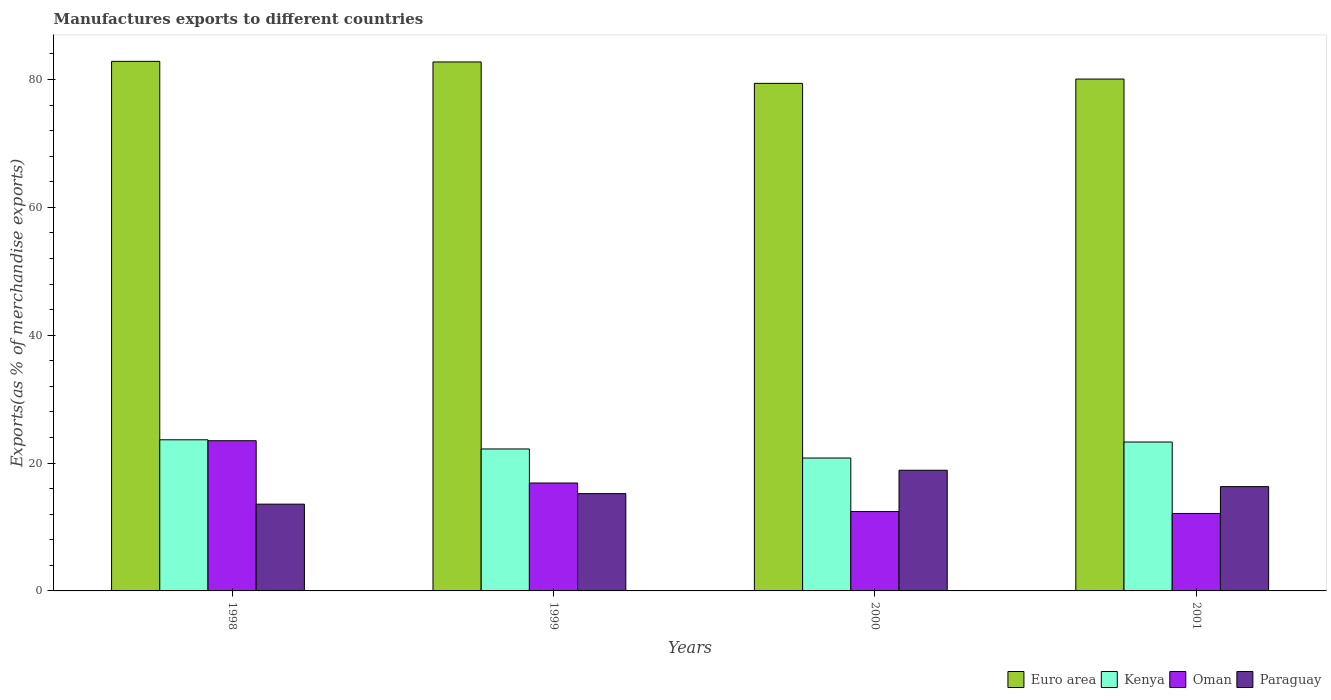Are the number of bars per tick equal to the number of legend labels?
Make the answer very short. Yes. Are the number of bars on each tick of the X-axis equal?
Ensure brevity in your answer.  Yes. How many bars are there on the 4th tick from the left?
Offer a very short reply. 4. What is the label of the 1st group of bars from the left?
Give a very brief answer. 1998. What is the percentage of exports to different countries in Paraguay in 1999?
Provide a short and direct response. 15.22. Across all years, what is the maximum percentage of exports to different countries in Kenya?
Offer a terse response. 23.64. Across all years, what is the minimum percentage of exports to different countries in Euro area?
Your answer should be very brief. 79.39. What is the total percentage of exports to different countries in Euro area in the graph?
Provide a succinct answer. 325.02. What is the difference between the percentage of exports to different countries in Paraguay in 1998 and that in 1999?
Your response must be concise. -1.65. What is the difference between the percentage of exports to different countries in Kenya in 2000 and the percentage of exports to different countries in Paraguay in 1998?
Offer a very short reply. 7.21. What is the average percentage of exports to different countries in Oman per year?
Offer a very short reply. 16.23. In the year 2000, what is the difference between the percentage of exports to different countries in Euro area and percentage of exports to different countries in Paraguay?
Provide a short and direct response. 60.51. What is the ratio of the percentage of exports to different countries in Paraguay in 1999 to that in 2001?
Make the answer very short. 0.93. Is the percentage of exports to different countries in Paraguay in 1998 less than that in 1999?
Make the answer very short. Yes. Is the difference between the percentage of exports to different countries in Euro area in 2000 and 2001 greater than the difference between the percentage of exports to different countries in Paraguay in 2000 and 2001?
Your answer should be very brief. No. What is the difference between the highest and the second highest percentage of exports to different countries in Euro area?
Give a very brief answer. 0.09. What is the difference between the highest and the lowest percentage of exports to different countries in Paraguay?
Offer a very short reply. 5.3. Is the sum of the percentage of exports to different countries in Oman in 2000 and 2001 greater than the maximum percentage of exports to different countries in Paraguay across all years?
Your response must be concise. Yes. Is it the case that in every year, the sum of the percentage of exports to different countries in Kenya and percentage of exports to different countries in Paraguay is greater than the sum of percentage of exports to different countries in Euro area and percentage of exports to different countries in Oman?
Ensure brevity in your answer.  Yes. What does the 2nd bar from the left in 1998 represents?
Your answer should be very brief. Kenya. What does the 1st bar from the right in 1998 represents?
Provide a succinct answer. Paraguay. Is it the case that in every year, the sum of the percentage of exports to different countries in Kenya and percentage of exports to different countries in Oman is greater than the percentage of exports to different countries in Paraguay?
Keep it short and to the point. Yes. Are all the bars in the graph horizontal?
Ensure brevity in your answer.  No. What is the difference between two consecutive major ticks on the Y-axis?
Your answer should be compact. 20. Are the values on the major ticks of Y-axis written in scientific E-notation?
Ensure brevity in your answer.  No. How are the legend labels stacked?
Your answer should be compact. Horizontal. What is the title of the graph?
Keep it short and to the point. Manufactures exports to different countries. What is the label or title of the X-axis?
Provide a succinct answer. Years. What is the label or title of the Y-axis?
Provide a succinct answer. Exports(as % of merchandise exports). What is the Exports(as % of merchandise exports) of Euro area in 1998?
Provide a succinct answer. 82.83. What is the Exports(as % of merchandise exports) in Kenya in 1998?
Give a very brief answer. 23.64. What is the Exports(as % of merchandise exports) in Oman in 1998?
Make the answer very short. 23.49. What is the Exports(as % of merchandise exports) in Paraguay in 1998?
Your response must be concise. 13.57. What is the Exports(as % of merchandise exports) in Euro area in 1999?
Your answer should be compact. 82.74. What is the Exports(as % of merchandise exports) in Kenya in 1999?
Give a very brief answer. 22.2. What is the Exports(as % of merchandise exports) of Oman in 1999?
Provide a succinct answer. 16.88. What is the Exports(as % of merchandise exports) of Paraguay in 1999?
Keep it short and to the point. 15.22. What is the Exports(as % of merchandise exports) in Euro area in 2000?
Provide a short and direct response. 79.39. What is the Exports(as % of merchandise exports) in Kenya in 2000?
Offer a terse response. 20.79. What is the Exports(as % of merchandise exports) in Oman in 2000?
Ensure brevity in your answer.  12.42. What is the Exports(as % of merchandise exports) in Paraguay in 2000?
Offer a very short reply. 18.88. What is the Exports(as % of merchandise exports) of Euro area in 2001?
Keep it short and to the point. 80.06. What is the Exports(as % of merchandise exports) in Kenya in 2001?
Offer a very short reply. 23.29. What is the Exports(as % of merchandise exports) in Oman in 2001?
Offer a very short reply. 12.12. What is the Exports(as % of merchandise exports) of Paraguay in 2001?
Your response must be concise. 16.31. Across all years, what is the maximum Exports(as % of merchandise exports) in Euro area?
Offer a terse response. 82.83. Across all years, what is the maximum Exports(as % of merchandise exports) of Kenya?
Your answer should be very brief. 23.64. Across all years, what is the maximum Exports(as % of merchandise exports) of Oman?
Make the answer very short. 23.49. Across all years, what is the maximum Exports(as % of merchandise exports) of Paraguay?
Provide a short and direct response. 18.88. Across all years, what is the minimum Exports(as % of merchandise exports) of Euro area?
Provide a succinct answer. 79.39. Across all years, what is the minimum Exports(as % of merchandise exports) of Kenya?
Offer a very short reply. 20.79. Across all years, what is the minimum Exports(as % of merchandise exports) in Oman?
Your response must be concise. 12.12. Across all years, what is the minimum Exports(as % of merchandise exports) in Paraguay?
Your answer should be compact. 13.57. What is the total Exports(as % of merchandise exports) in Euro area in the graph?
Your response must be concise. 325.02. What is the total Exports(as % of merchandise exports) of Kenya in the graph?
Offer a terse response. 89.92. What is the total Exports(as % of merchandise exports) of Oman in the graph?
Ensure brevity in your answer.  64.9. What is the total Exports(as % of merchandise exports) in Paraguay in the graph?
Keep it short and to the point. 63.98. What is the difference between the Exports(as % of merchandise exports) of Euro area in 1998 and that in 1999?
Make the answer very short. 0.09. What is the difference between the Exports(as % of merchandise exports) of Kenya in 1998 and that in 1999?
Your answer should be compact. 1.44. What is the difference between the Exports(as % of merchandise exports) of Oman in 1998 and that in 1999?
Your answer should be compact. 6.61. What is the difference between the Exports(as % of merchandise exports) in Paraguay in 1998 and that in 1999?
Your answer should be compact. -1.65. What is the difference between the Exports(as % of merchandise exports) of Euro area in 1998 and that in 2000?
Keep it short and to the point. 3.44. What is the difference between the Exports(as % of merchandise exports) of Kenya in 1998 and that in 2000?
Your response must be concise. 2.85. What is the difference between the Exports(as % of merchandise exports) of Oman in 1998 and that in 2000?
Your answer should be very brief. 11.08. What is the difference between the Exports(as % of merchandise exports) of Paraguay in 1998 and that in 2000?
Make the answer very short. -5.3. What is the difference between the Exports(as % of merchandise exports) in Euro area in 1998 and that in 2001?
Offer a very short reply. 2.77. What is the difference between the Exports(as % of merchandise exports) in Kenya in 1998 and that in 2001?
Keep it short and to the point. 0.35. What is the difference between the Exports(as % of merchandise exports) in Oman in 1998 and that in 2001?
Keep it short and to the point. 11.38. What is the difference between the Exports(as % of merchandise exports) in Paraguay in 1998 and that in 2001?
Provide a succinct answer. -2.74. What is the difference between the Exports(as % of merchandise exports) of Euro area in 1999 and that in 2000?
Your response must be concise. 3.35. What is the difference between the Exports(as % of merchandise exports) in Kenya in 1999 and that in 2000?
Offer a very short reply. 1.42. What is the difference between the Exports(as % of merchandise exports) of Oman in 1999 and that in 2000?
Keep it short and to the point. 4.46. What is the difference between the Exports(as % of merchandise exports) of Paraguay in 1999 and that in 2000?
Give a very brief answer. -3.66. What is the difference between the Exports(as % of merchandise exports) of Euro area in 1999 and that in 2001?
Offer a very short reply. 2.67. What is the difference between the Exports(as % of merchandise exports) in Kenya in 1999 and that in 2001?
Make the answer very short. -1.09. What is the difference between the Exports(as % of merchandise exports) of Oman in 1999 and that in 2001?
Offer a terse response. 4.76. What is the difference between the Exports(as % of merchandise exports) in Paraguay in 1999 and that in 2001?
Your response must be concise. -1.09. What is the difference between the Exports(as % of merchandise exports) of Euro area in 2000 and that in 2001?
Your response must be concise. -0.67. What is the difference between the Exports(as % of merchandise exports) in Kenya in 2000 and that in 2001?
Ensure brevity in your answer.  -2.5. What is the difference between the Exports(as % of merchandise exports) of Oman in 2000 and that in 2001?
Offer a terse response. 0.3. What is the difference between the Exports(as % of merchandise exports) in Paraguay in 2000 and that in 2001?
Your answer should be very brief. 2.56. What is the difference between the Exports(as % of merchandise exports) in Euro area in 1998 and the Exports(as % of merchandise exports) in Kenya in 1999?
Your response must be concise. 60.63. What is the difference between the Exports(as % of merchandise exports) of Euro area in 1998 and the Exports(as % of merchandise exports) of Oman in 1999?
Your response must be concise. 65.95. What is the difference between the Exports(as % of merchandise exports) in Euro area in 1998 and the Exports(as % of merchandise exports) in Paraguay in 1999?
Your answer should be very brief. 67.61. What is the difference between the Exports(as % of merchandise exports) in Kenya in 1998 and the Exports(as % of merchandise exports) in Oman in 1999?
Give a very brief answer. 6.76. What is the difference between the Exports(as % of merchandise exports) in Kenya in 1998 and the Exports(as % of merchandise exports) in Paraguay in 1999?
Your response must be concise. 8.42. What is the difference between the Exports(as % of merchandise exports) of Oman in 1998 and the Exports(as % of merchandise exports) of Paraguay in 1999?
Your answer should be very brief. 8.27. What is the difference between the Exports(as % of merchandise exports) in Euro area in 1998 and the Exports(as % of merchandise exports) in Kenya in 2000?
Your answer should be very brief. 62.04. What is the difference between the Exports(as % of merchandise exports) in Euro area in 1998 and the Exports(as % of merchandise exports) in Oman in 2000?
Ensure brevity in your answer.  70.42. What is the difference between the Exports(as % of merchandise exports) in Euro area in 1998 and the Exports(as % of merchandise exports) in Paraguay in 2000?
Provide a succinct answer. 63.95. What is the difference between the Exports(as % of merchandise exports) of Kenya in 1998 and the Exports(as % of merchandise exports) of Oman in 2000?
Your response must be concise. 11.22. What is the difference between the Exports(as % of merchandise exports) of Kenya in 1998 and the Exports(as % of merchandise exports) of Paraguay in 2000?
Offer a very short reply. 4.76. What is the difference between the Exports(as % of merchandise exports) of Oman in 1998 and the Exports(as % of merchandise exports) of Paraguay in 2000?
Give a very brief answer. 4.62. What is the difference between the Exports(as % of merchandise exports) in Euro area in 1998 and the Exports(as % of merchandise exports) in Kenya in 2001?
Your answer should be very brief. 59.54. What is the difference between the Exports(as % of merchandise exports) in Euro area in 1998 and the Exports(as % of merchandise exports) in Oman in 2001?
Ensure brevity in your answer.  70.72. What is the difference between the Exports(as % of merchandise exports) in Euro area in 1998 and the Exports(as % of merchandise exports) in Paraguay in 2001?
Your answer should be compact. 66.52. What is the difference between the Exports(as % of merchandise exports) in Kenya in 1998 and the Exports(as % of merchandise exports) in Oman in 2001?
Ensure brevity in your answer.  11.52. What is the difference between the Exports(as % of merchandise exports) in Kenya in 1998 and the Exports(as % of merchandise exports) in Paraguay in 2001?
Keep it short and to the point. 7.33. What is the difference between the Exports(as % of merchandise exports) in Oman in 1998 and the Exports(as % of merchandise exports) in Paraguay in 2001?
Make the answer very short. 7.18. What is the difference between the Exports(as % of merchandise exports) in Euro area in 1999 and the Exports(as % of merchandise exports) in Kenya in 2000?
Your answer should be compact. 61.95. What is the difference between the Exports(as % of merchandise exports) of Euro area in 1999 and the Exports(as % of merchandise exports) of Oman in 2000?
Offer a terse response. 70.32. What is the difference between the Exports(as % of merchandise exports) of Euro area in 1999 and the Exports(as % of merchandise exports) of Paraguay in 2000?
Keep it short and to the point. 63.86. What is the difference between the Exports(as % of merchandise exports) in Kenya in 1999 and the Exports(as % of merchandise exports) in Oman in 2000?
Your answer should be very brief. 9.79. What is the difference between the Exports(as % of merchandise exports) of Kenya in 1999 and the Exports(as % of merchandise exports) of Paraguay in 2000?
Make the answer very short. 3.33. What is the difference between the Exports(as % of merchandise exports) in Oman in 1999 and the Exports(as % of merchandise exports) in Paraguay in 2000?
Your answer should be compact. -2. What is the difference between the Exports(as % of merchandise exports) of Euro area in 1999 and the Exports(as % of merchandise exports) of Kenya in 2001?
Offer a very short reply. 59.45. What is the difference between the Exports(as % of merchandise exports) in Euro area in 1999 and the Exports(as % of merchandise exports) in Oman in 2001?
Keep it short and to the point. 70.62. What is the difference between the Exports(as % of merchandise exports) of Euro area in 1999 and the Exports(as % of merchandise exports) of Paraguay in 2001?
Ensure brevity in your answer.  66.42. What is the difference between the Exports(as % of merchandise exports) in Kenya in 1999 and the Exports(as % of merchandise exports) in Oman in 2001?
Provide a short and direct response. 10.09. What is the difference between the Exports(as % of merchandise exports) in Kenya in 1999 and the Exports(as % of merchandise exports) in Paraguay in 2001?
Your answer should be compact. 5.89. What is the difference between the Exports(as % of merchandise exports) of Oman in 1999 and the Exports(as % of merchandise exports) of Paraguay in 2001?
Your answer should be very brief. 0.57. What is the difference between the Exports(as % of merchandise exports) in Euro area in 2000 and the Exports(as % of merchandise exports) in Kenya in 2001?
Keep it short and to the point. 56.1. What is the difference between the Exports(as % of merchandise exports) in Euro area in 2000 and the Exports(as % of merchandise exports) in Oman in 2001?
Offer a very short reply. 67.27. What is the difference between the Exports(as % of merchandise exports) in Euro area in 2000 and the Exports(as % of merchandise exports) in Paraguay in 2001?
Provide a succinct answer. 63.07. What is the difference between the Exports(as % of merchandise exports) of Kenya in 2000 and the Exports(as % of merchandise exports) of Oman in 2001?
Offer a terse response. 8.67. What is the difference between the Exports(as % of merchandise exports) of Kenya in 2000 and the Exports(as % of merchandise exports) of Paraguay in 2001?
Make the answer very short. 4.47. What is the difference between the Exports(as % of merchandise exports) in Oman in 2000 and the Exports(as % of merchandise exports) in Paraguay in 2001?
Provide a succinct answer. -3.9. What is the average Exports(as % of merchandise exports) in Euro area per year?
Keep it short and to the point. 81.25. What is the average Exports(as % of merchandise exports) of Kenya per year?
Provide a short and direct response. 22.48. What is the average Exports(as % of merchandise exports) in Oman per year?
Keep it short and to the point. 16.23. What is the average Exports(as % of merchandise exports) of Paraguay per year?
Keep it short and to the point. 16. In the year 1998, what is the difference between the Exports(as % of merchandise exports) of Euro area and Exports(as % of merchandise exports) of Kenya?
Give a very brief answer. 59.19. In the year 1998, what is the difference between the Exports(as % of merchandise exports) in Euro area and Exports(as % of merchandise exports) in Oman?
Provide a short and direct response. 59.34. In the year 1998, what is the difference between the Exports(as % of merchandise exports) in Euro area and Exports(as % of merchandise exports) in Paraguay?
Provide a short and direct response. 69.26. In the year 1998, what is the difference between the Exports(as % of merchandise exports) in Kenya and Exports(as % of merchandise exports) in Oman?
Provide a succinct answer. 0.15. In the year 1998, what is the difference between the Exports(as % of merchandise exports) in Kenya and Exports(as % of merchandise exports) in Paraguay?
Your response must be concise. 10.06. In the year 1998, what is the difference between the Exports(as % of merchandise exports) of Oman and Exports(as % of merchandise exports) of Paraguay?
Your answer should be compact. 9.92. In the year 1999, what is the difference between the Exports(as % of merchandise exports) of Euro area and Exports(as % of merchandise exports) of Kenya?
Make the answer very short. 60.53. In the year 1999, what is the difference between the Exports(as % of merchandise exports) of Euro area and Exports(as % of merchandise exports) of Oman?
Your answer should be very brief. 65.86. In the year 1999, what is the difference between the Exports(as % of merchandise exports) of Euro area and Exports(as % of merchandise exports) of Paraguay?
Your answer should be compact. 67.52. In the year 1999, what is the difference between the Exports(as % of merchandise exports) in Kenya and Exports(as % of merchandise exports) in Oman?
Offer a terse response. 5.33. In the year 1999, what is the difference between the Exports(as % of merchandise exports) of Kenya and Exports(as % of merchandise exports) of Paraguay?
Your answer should be compact. 6.98. In the year 1999, what is the difference between the Exports(as % of merchandise exports) in Oman and Exports(as % of merchandise exports) in Paraguay?
Give a very brief answer. 1.66. In the year 2000, what is the difference between the Exports(as % of merchandise exports) of Euro area and Exports(as % of merchandise exports) of Kenya?
Offer a very short reply. 58.6. In the year 2000, what is the difference between the Exports(as % of merchandise exports) of Euro area and Exports(as % of merchandise exports) of Oman?
Keep it short and to the point. 66.97. In the year 2000, what is the difference between the Exports(as % of merchandise exports) of Euro area and Exports(as % of merchandise exports) of Paraguay?
Provide a succinct answer. 60.51. In the year 2000, what is the difference between the Exports(as % of merchandise exports) in Kenya and Exports(as % of merchandise exports) in Oman?
Give a very brief answer. 8.37. In the year 2000, what is the difference between the Exports(as % of merchandise exports) of Kenya and Exports(as % of merchandise exports) of Paraguay?
Your response must be concise. 1.91. In the year 2000, what is the difference between the Exports(as % of merchandise exports) of Oman and Exports(as % of merchandise exports) of Paraguay?
Your answer should be very brief. -6.46. In the year 2001, what is the difference between the Exports(as % of merchandise exports) of Euro area and Exports(as % of merchandise exports) of Kenya?
Ensure brevity in your answer.  56.77. In the year 2001, what is the difference between the Exports(as % of merchandise exports) in Euro area and Exports(as % of merchandise exports) in Oman?
Your answer should be compact. 67.95. In the year 2001, what is the difference between the Exports(as % of merchandise exports) in Euro area and Exports(as % of merchandise exports) in Paraguay?
Ensure brevity in your answer.  63.75. In the year 2001, what is the difference between the Exports(as % of merchandise exports) of Kenya and Exports(as % of merchandise exports) of Oman?
Offer a terse response. 11.17. In the year 2001, what is the difference between the Exports(as % of merchandise exports) of Kenya and Exports(as % of merchandise exports) of Paraguay?
Keep it short and to the point. 6.98. In the year 2001, what is the difference between the Exports(as % of merchandise exports) of Oman and Exports(as % of merchandise exports) of Paraguay?
Ensure brevity in your answer.  -4.2. What is the ratio of the Exports(as % of merchandise exports) in Euro area in 1998 to that in 1999?
Offer a terse response. 1. What is the ratio of the Exports(as % of merchandise exports) in Kenya in 1998 to that in 1999?
Make the answer very short. 1.06. What is the ratio of the Exports(as % of merchandise exports) of Oman in 1998 to that in 1999?
Your answer should be very brief. 1.39. What is the ratio of the Exports(as % of merchandise exports) in Paraguay in 1998 to that in 1999?
Give a very brief answer. 0.89. What is the ratio of the Exports(as % of merchandise exports) in Euro area in 1998 to that in 2000?
Provide a short and direct response. 1.04. What is the ratio of the Exports(as % of merchandise exports) of Kenya in 1998 to that in 2000?
Provide a short and direct response. 1.14. What is the ratio of the Exports(as % of merchandise exports) in Oman in 1998 to that in 2000?
Provide a short and direct response. 1.89. What is the ratio of the Exports(as % of merchandise exports) of Paraguay in 1998 to that in 2000?
Give a very brief answer. 0.72. What is the ratio of the Exports(as % of merchandise exports) of Euro area in 1998 to that in 2001?
Provide a succinct answer. 1.03. What is the ratio of the Exports(as % of merchandise exports) in Kenya in 1998 to that in 2001?
Ensure brevity in your answer.  1.01. What is the ratio of the Exports(as % of merchandise exports) of Oman in 1998 to that in 2001?
Your response must be concise. 1.94. What is the ratio of the Exports(as % of merchandise exports) of Paraguay in 1998 to that in 2001?
Provide a succinct answer. 0.83. What is the ratio of the Exports(as % of merchandise exports) of Euro area in 1999 to that in 2000?
Your answer should be compact. 1.04. What is the ratio of the Exports(as % of merchandise exports) in Kenya in 1999 to that in 2000?
Offer a very short reply. 1.07. What is the ratio of the Exports(as % of merchandise exports) in Oman in 1999 to that in 2000?
Your response must be concise. 1.36. What is the ratio of the Exports(as % of merchandise exports) of Paraguay in 1999 to that in 2000?
Provide a short and direct response. 0.81. What is the ratio of the Exports(as % of merchandise exports) in Euro area in 1999 to that in 2001?
Offer a terse response. 1.03. What is the ratio of the Exports(as % of merchandise exports) in Kenya in 1999 to that in 2001?
Give a very brief answer. 0.95. What is the ratio of the Exports(as % of merchandise exports) of Oman in 1999 to that in 2001?
Provide a succinct answer. 1.39. What is the ratio of the Exports(as % of merchandise exports) of Paraguay in 1999 to that in 2001?
Provide a short and direct response. 0.93. What is the ratio of the Exports(as % of merchandise exports) of Kenya in 2000 to that in 2001?
Ensure brevity in your answer.  0.89. What is the ratio of the Exports(as % of merchandise exports) in Oman in 2000 to that in 2001?
Offer a very short reply. 1.02. What is the ratio of the Exports(as % of merchandise exports) in Paraguay in 2000 to that in 2001?
Offer a terse response. 1.16. What is the difference between the highest and the second highest Exports(as % of merchandise exports) of Euro area?
Provide a succinct answer. 0.09. What is the difference between the highest and the second highest Exports(as % of merchandise exports) of Kenya?
Make the answer very short. 0.35. What is the difference between the highest and the second highest Exports(as % of merchandise exports) in Oman?
Offer a terse response. 6.61. What is the difference between the highest and the second highest Exports(as % of merchandise exports) in Paraguay?
Make the answer very short. 2.56. What is the difference between the highest and the lowest Exports(as % of merchandise exports) of Euro area?
Provide a short and direct response. 3.44. What is the difference between the highest and the lowest Exports(as % of merchandise exports) in Kenya?
Ensure brevity in your answer.  2.85. What is the difference between the highest and the lowest Exports(as % of merchandise exports) in Oman?
Offer a terse response. 11.38. What is the difference between the highest and the lowest Exports(as % of merchandise exports) of Paraguay?
Offer a terse response. 5.3. 